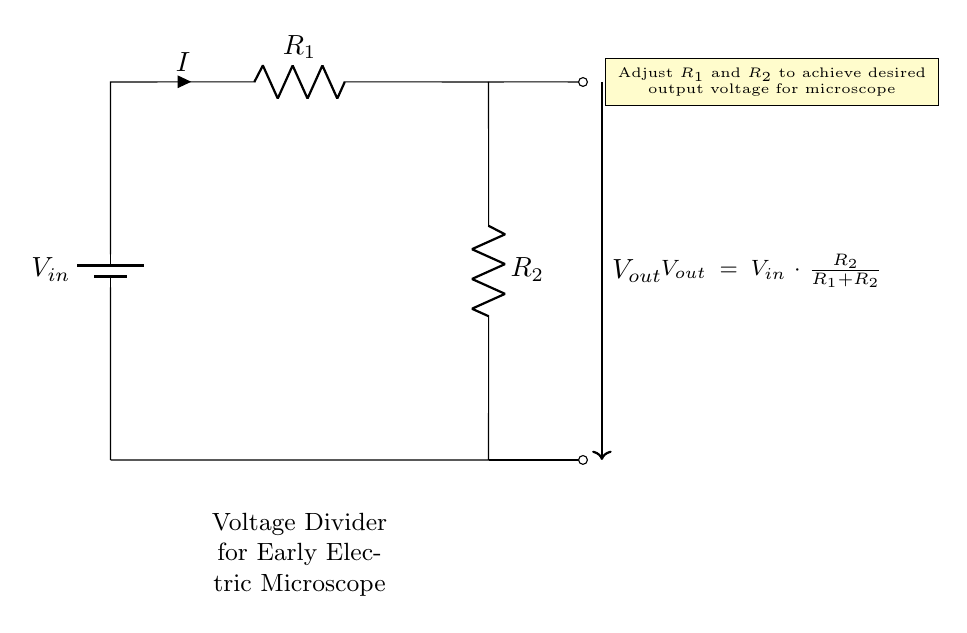What is the input voltage in the circuit? The input voltage is denoted as \( V_{in} \) at the top of the circuit by the battery symbol, indicating where the voltage supply is connected.
Answer: \( V_{in} \) What are the components used in this voltage divider? The components in the voltage divider circuit are a voltage source (battery), two resistors (\( R_1 \) and \( R_2 \)), and connections represented by lines.
Answer: Battery, R1, R2 What is the formula for the output voltage? The output voltage is expressed in the circuit diagram as \( V_{out} = V_{in} \cdot \frac{R_2}{R_1 + R_2} \), which describes how the output voltage relates to the input and the resistances.
Answer: \( V_{out} = V_{in} \cdot \frac{R_2}{R_1 + R_2} \) How can you adjust the output voltage? The output voltage can be adjusted by varying the values of \( R_1 \) and \( R_2 \) in the circuit, as indicated in the note that suggests changing these resistors for desired results.
Answer: By adjusting R1 and R2 What happens to the output voltage if \( R_1 \) increases? If \( R_1 \) increases, the denominator \( R_1 + R_2 \) in the output voltage formula increases, leading to a decrease in \( V_{out} \) since a larger resistor reduces the overall output voltage for a given \( V_{in} \).
Answer: Decreases If both resistors are the same value, what is the output voltage equal to? When both resistors have the same resistance value, the output voltage \( V_{out} \) equals half of the input voltage \( V_{in} \), as they divide the voltage equally.
Answer: \( \frac{V_{in}}{2} \) 